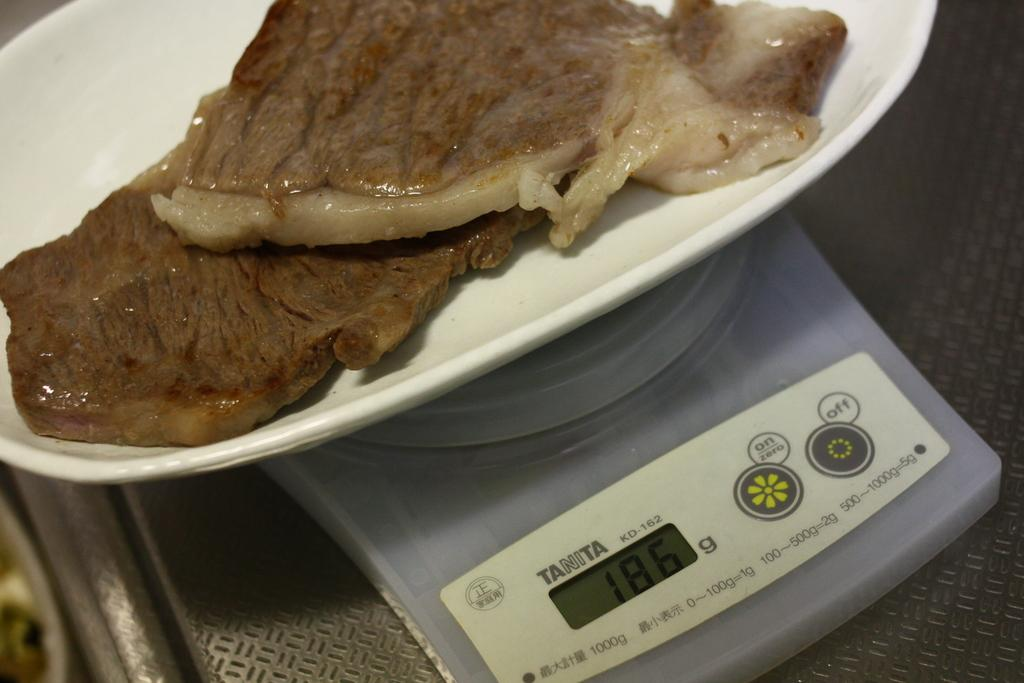What is the main object in the image? There is a weighing machine in the image. What is placed on the pan of the weighing machine? There is non-vegetarian food on the pan of the weighing machine. Can you see a rose on the weighing machine in the image? There is no rose present on the weighing machine in the image. Is the weighing machine made of plastic in the image? The material of the weighing machine is not mentioned in the provided facts, so it cannot be determined from the image. 